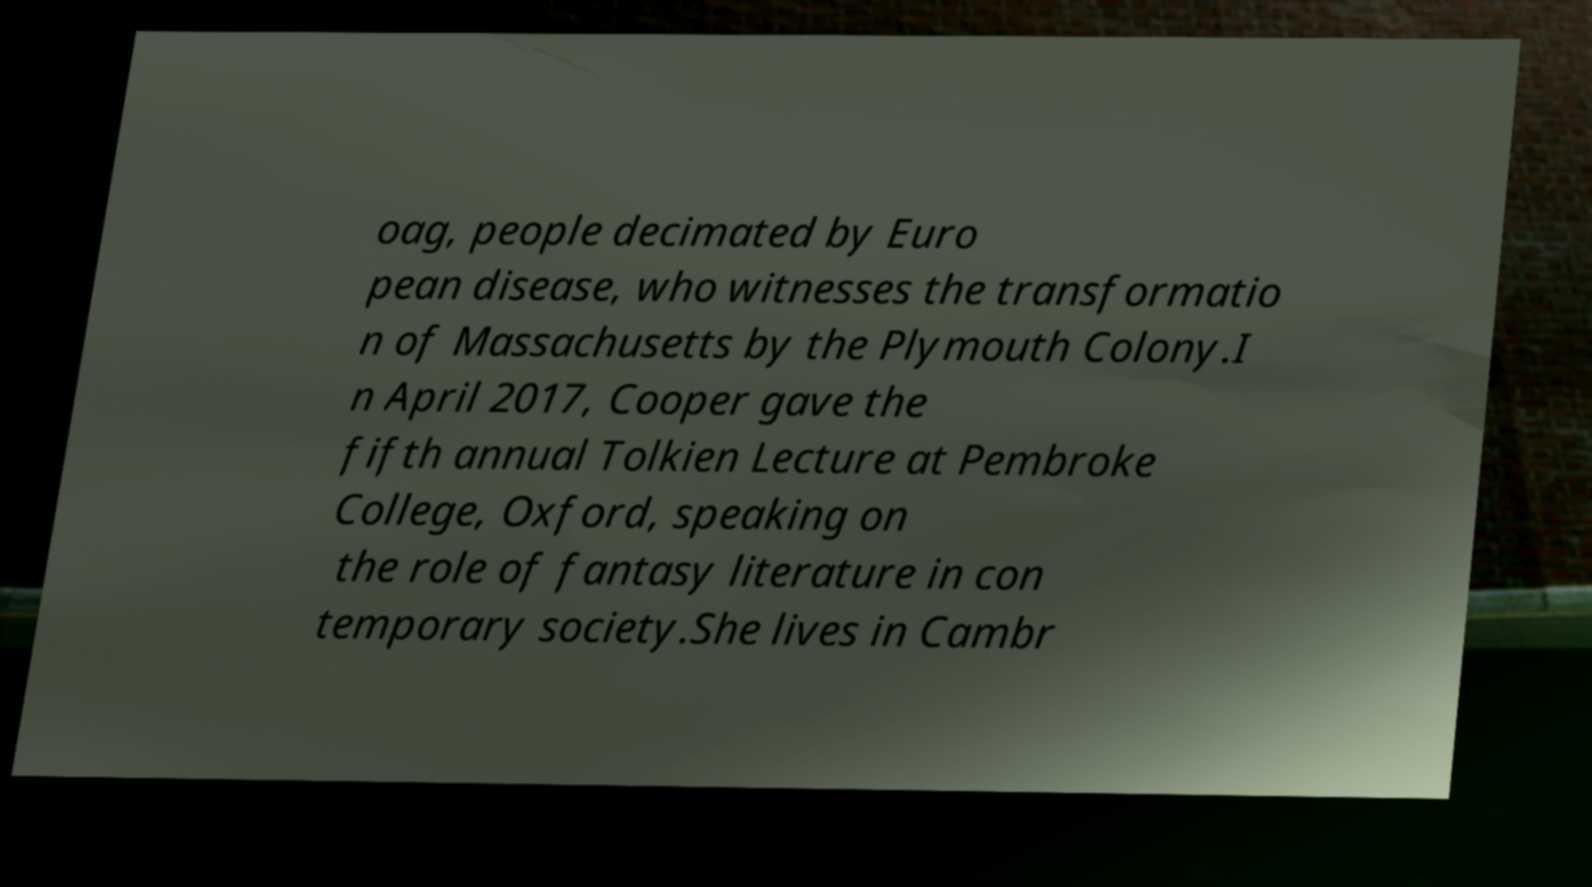Could you extract and type out the text from this image? oag, people decimated by Euro pean disease, who witnesses the transformatio n of Massachusetts by the Plymouth Colony.I n April 2017, Cooper gave the fifth annual Tolkien Lecture at Pembroke College, Oxford, speaking on the role of fantasy literature in con temporary society.She lives in Cambr 